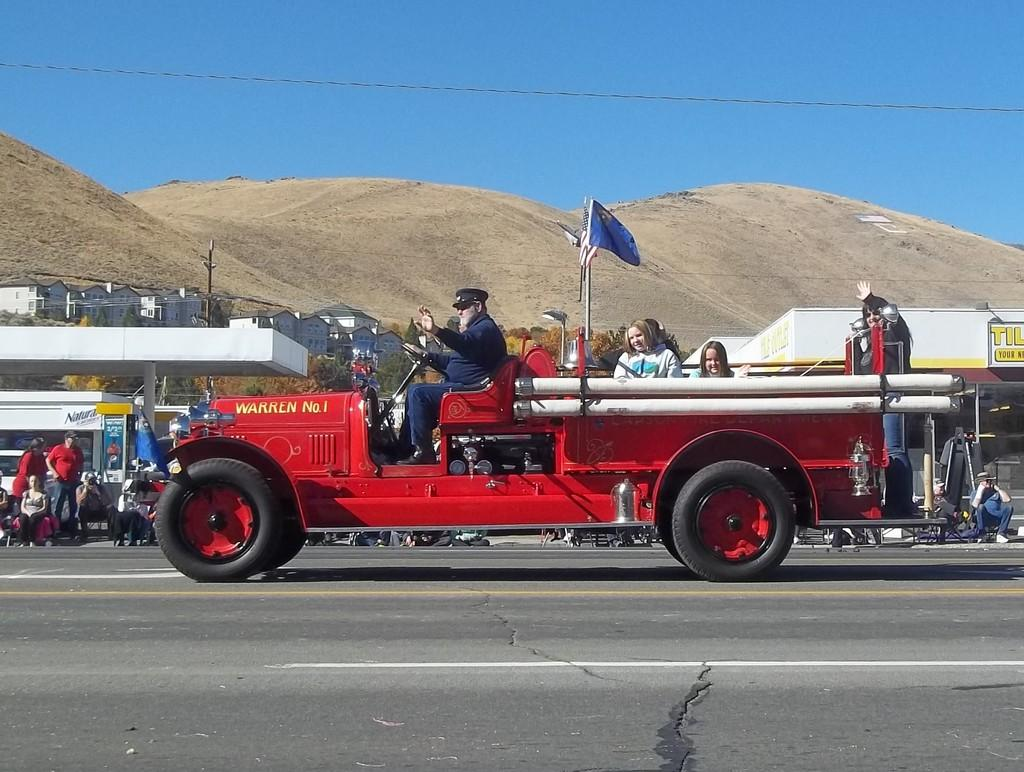What is happening inside the vehicle in the image? There are persons in the vehicle. What can be seen inside the vehicle with the persons? There is a flag in the vehicle. What is visible in the middle of the image? There are buildings and hills in the middle of the image. What is visible at the top of the image? There is a sky at the top of the image. What type of soap is being used to clean the buildings in the image? There is no soap or cleaning activity depicted in the image; it only shows buildings, hills, and a sky. What time is displayed on the watch in the image? There is no watch present in the image. 